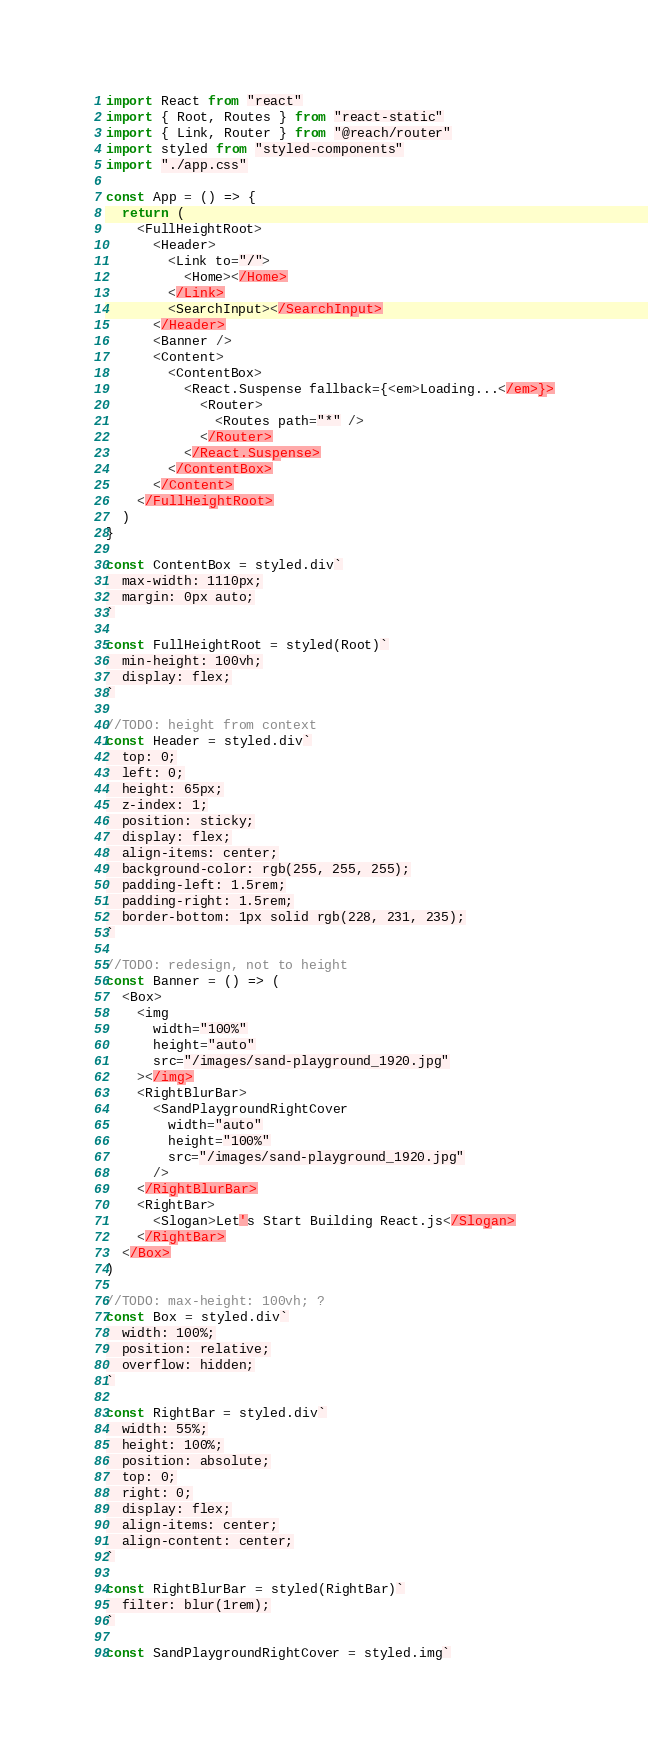<code> <loc_0><loc_0><loc_500><loc_500><_JavaScript_>import React from "react"
import { Root, Routes } from "react-static"
import { Link, Router } from "@reach/router"
import styled from "styled-components"
import "./app.css"

const App = () => {
  return (
    <FullHeightRoot>
      <Header>
        <Link to="/">
          <Home></Home>
        </Link>
        <SearchInput></SearchInput>
      </Header>
      <Banner />
      <Content>
        <ContentBox>
          <React.Suspense fallback={<em>Loading...</em>}>
            <Router>
              <Routes path="*" />
            </Router>
          </React.Suspense>
        </ContentBox>
      </Content>
    </FullHeightRoot>
  )
}

const ContentBox = styled.div`
  max-width: 1110px;
  margin: 0px auto;
`

const FullHeightRoot = styled(Root)`
  min-height: 100vh;
  display: flex;
`

//TODO: height from context
const Header = styled.div`
  top: 0;
  left: 0;
  height: 65px;
  z-index: 1;
  position: sticky;
  display: flex;
  align-items: center;
  background-color: rgb(255, 255, 255);
  padding-left: 1.5rem;
  padding-right: 1.5rem;
  border-bottom: 1px solid rgb(228, 231, 235);
`

//TODO: redesign, not to height
const Banner = () => (
  <Box>
    <img
      width="100%"
      height="auto"
      src="/images/sand-playground_1920.jpg"
    ></img>
    <RightBlurBar>
      <SandPlaygroundRightCover
        width="auto"
        height="100%"
        src="/images/sand-playground_1920.jpg"
      />
    </RightBlurBar>
    <RightBar>
      <Slogan>Let's Start Building React.js</Slogan>
    </RightBar>
  </Box>
)

//TODO: max-height: 100vh; ?
const Box = styled.div`
  width: 100%;
  position: relative;
  overflow: hidden;
`

const RightBar = styled.div`
  width: 55%;
  height: 100%;
  position: absolute;
  top: 0;
  right: 0;
  display: flex;
  align-items: center;
  align-content: center;
`

const RightBlurBar = styled(RightBar)`
  filter: blur(1rem);
`

const SandPlaygroundRightCover = styled.img`</code> 